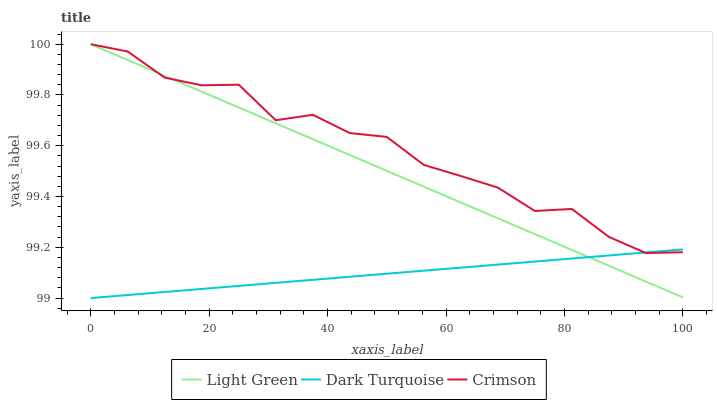Does Dark Turquoise have the minimum area under the curve?
Answer yes or no. Yes. Does Crimson have the maximum area under the curve?
Answer yes or no. Yes. Does Light Green have the minimum area under the curve?
Answer yes or no. No. Does Light Green have the maximum area under the curve?
Answer yes or no. No. Is Dark Turquoise the smoothest?
Answer yes or no. Yes. Is Crimson the roughest?
Answer yes or no. Yes. Is Light Green the smoothest?
Answer yes or no. No. Is Light Green the roughest?
Answer yes or no. No. Does Dark Turquoise have the lowest value?
Answer yes or no. Yes. Does Light Green have the lowest value?
Answer yes or no. No. Does Light Green have the highest value?
Answer yes or no. Yes. Does Dark Turquoise have the highest value?
Answer yes or no. No. Does Crimson intersect Dark Turquoise?
Answer yes or no. Yes. Is Crimson less than Dark Turquoise?
Answer yes or no. No. Is Crimson greater than Dark Turquoise?
Answer yes or no. No. 